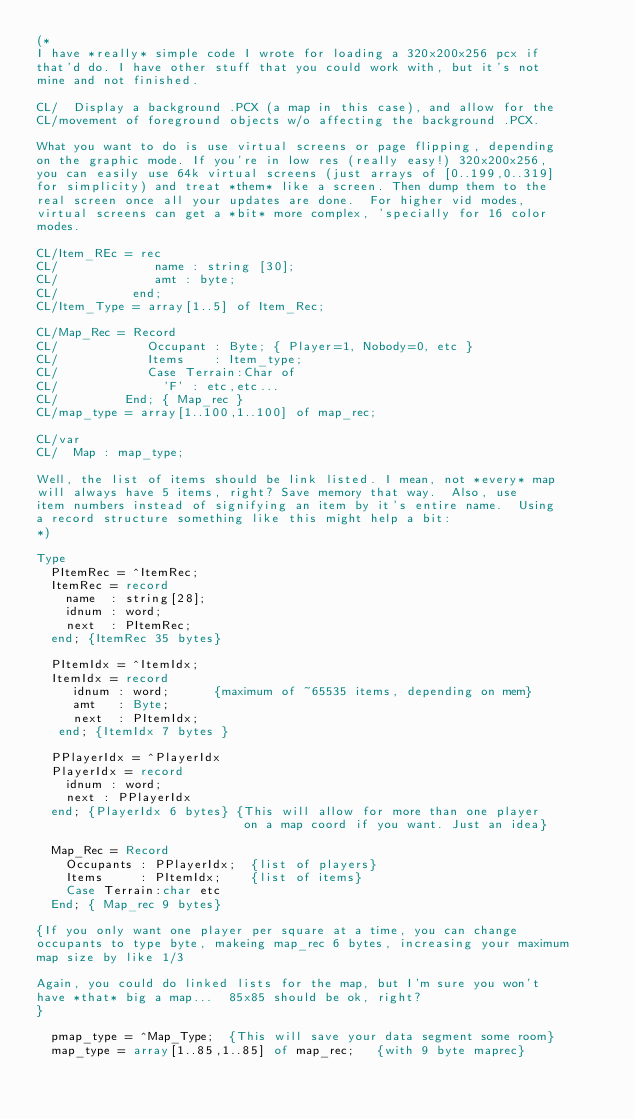<code> <loc_0><loc_0><loc_500><loc_500><_Pascal_>(*
I have *really* simple code I wrote for loading a 320x200x256 pcx if
that'd do. I have other stuff that you could work with, but it's not
mine and not finished.

CL/  Display a background .PCX (a map in this case), and allow for the
CL/movement of foreground objects w/o affecting the background .PCX.

What you want to do is use virtual screens or page flipping, depending
on the graphic mode. If you're in low res (really easy!) 320x200x256,
you can easily use 64k virtual screens (just arrays of [0..199,0..319]
for simplicity) and treat *them* like a screen. Then dump them to the
real screen once all your updates are done.  For higher vid modes,
virtual screens can get a *bit* more complex, 'specially for 16 color
modes.

CL/Item_REc = rec
CL/             name : string [30];
CL/             amt : byte;
CL/          end;
CL/Item_Type = array[1..5] of Item_Rec;

CL/Map_Rec = Record
CL/            Occupant : Byte; { Player=1, Nobody=0, etc }
CL/            Items    : Item_type;
CL/            Case Terrain:Char of
CL/              'F' : etc,etc...
CL/         End; { Map_rec }
CL/map_type = array[1..100,1..100] of map_rec;

CL/var
CL/  Map : map_type;

Well, the list of items should be link listed. I mean, not *every* map
will always have 5 items, right? Save memory that way.  Also, use
item numbers instead of signifying an item by it's entire name.  Using
a record structure something like this might help a bit:
*)

Type
  PItemRec = ^ItemRec;
  ItemRec = record
    name  : string[28];
    idnum : word;
    next  : PItemRec;
  end; {ItemRec 35 bytes}

  PItemIdx = ^ItemIdx;
  ItemIdx = record
     idnum : word;      {maximum of ~65535 items, depending on mem}
     amt   : Byte;
     next  : PItemIdx;
   end; {ItemIdx 7 bytes }

  PPlayerIdx = ^PlayerIdx
  PlayerIdx = record
    idnum : word;
    next : PPlayerIdx
  end; {PlayerIdx 6 bytes} {This will allow for more than one player
                            on a map coord if you want. Just an idea}

  Map_Rec = Record
    Occupants : PPlayerIdx;  {list of players}
    Items     : PItemIdx;    {list of items}
    Case Terrain:char etc
  End; { Map_rec 9 bytes}

{If you only want one player per square at a time, you can change
occupants to type byte, makeing map_rec 6 bytes, increasing your maximum
map size by like 1/3

Again, you could do linked lists for the map, but I'm sure you won't
have *that* big a map...  85x85 should be ok, right?
}

  pmap_type = ^Map_Type;  {This will save your data segment some room}
  map_type = array[1..85,1..85] of map_rec;   {with 9 byte maprec}</code> 